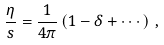<formula> <loc_0><loc_0><loc_500><loc_500>\frac { \eta } { s } = \frac { 1 } { 4 \pi } \left ( 1 - \delta + \cdots \right ) \, , \label l { e t a s 2 }</formula> 